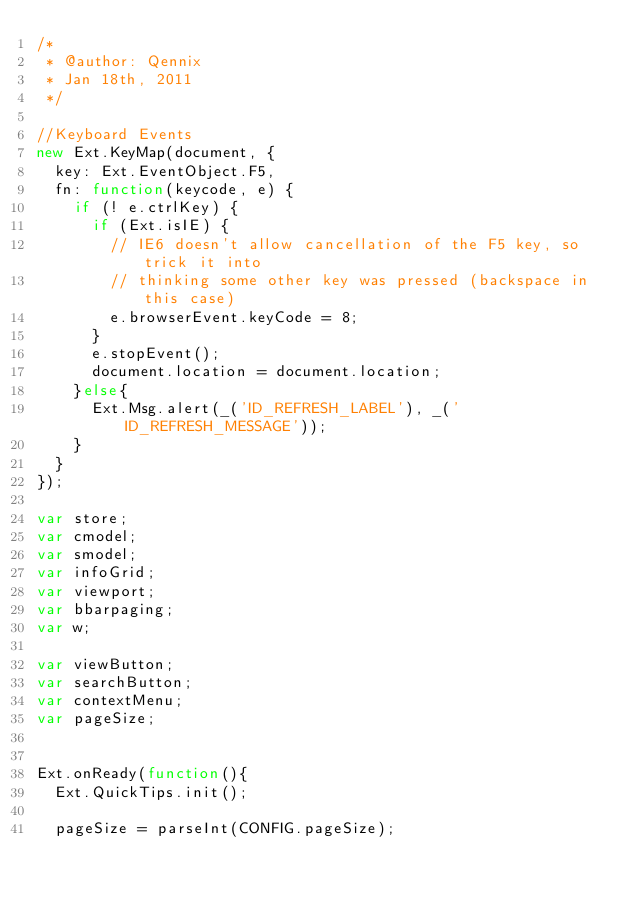<code> <loc_0><loc_0><loc_500><loc_500><_JavaScript_>/*
 * @author: Qennix
 * Jan 18th, 2011
 */

//Keyboard Events
new Ext.KeyMap(document, {
  key: Ext.EventObject.F5,
  fn: function(keycode, e) {
    if (! e.ctrlKey) {
      if (Ext.isIE) {
        // IE6 doesn't allow cancellation of the F5 key, so trick it into
        // thinking some other key was pressed (backspace in this case)
        e.browserEvent.keyCode = 8;
      }
      e.stopEvent();
      document.location = document.location;
    }else{
      Ext.Msg.alert(_('ID_REFRESH_LABEL'), _('ID_REFRESH_MESSAGE'));
    }
  }
});

var store;
var cmodel;
var smodel;
var infoGrid;
var viewport;
var bbarpaging;
var w;

var viewButton;
var searchButton;
var contextMenu;
var pageSize;


Ext.onReady(function(){
  Ext.QuickTips.init();

  pageSize = parseInt(CONFIG.pageSize);
</code> 